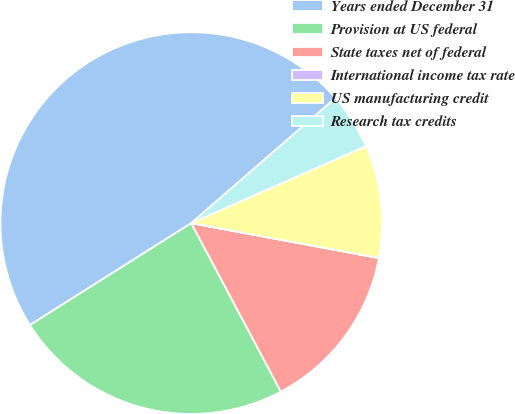Convert chart to OTSL. <chart><loc_0><loc_0><loc_500><loc_500><pie_chart><fcel>Years ended December 31<fcel>Provision at US federal<fcel>State taxes net of federal<fcel>International income tax rate<fcel>US manufacturing credit<fcel>Research tax credits<nl><fcel>47.6%<fcel>23.81%<fcel>14.29%<fcel>0.01%<fcel>9.53%<fcel>4.77%<nl></chart> 